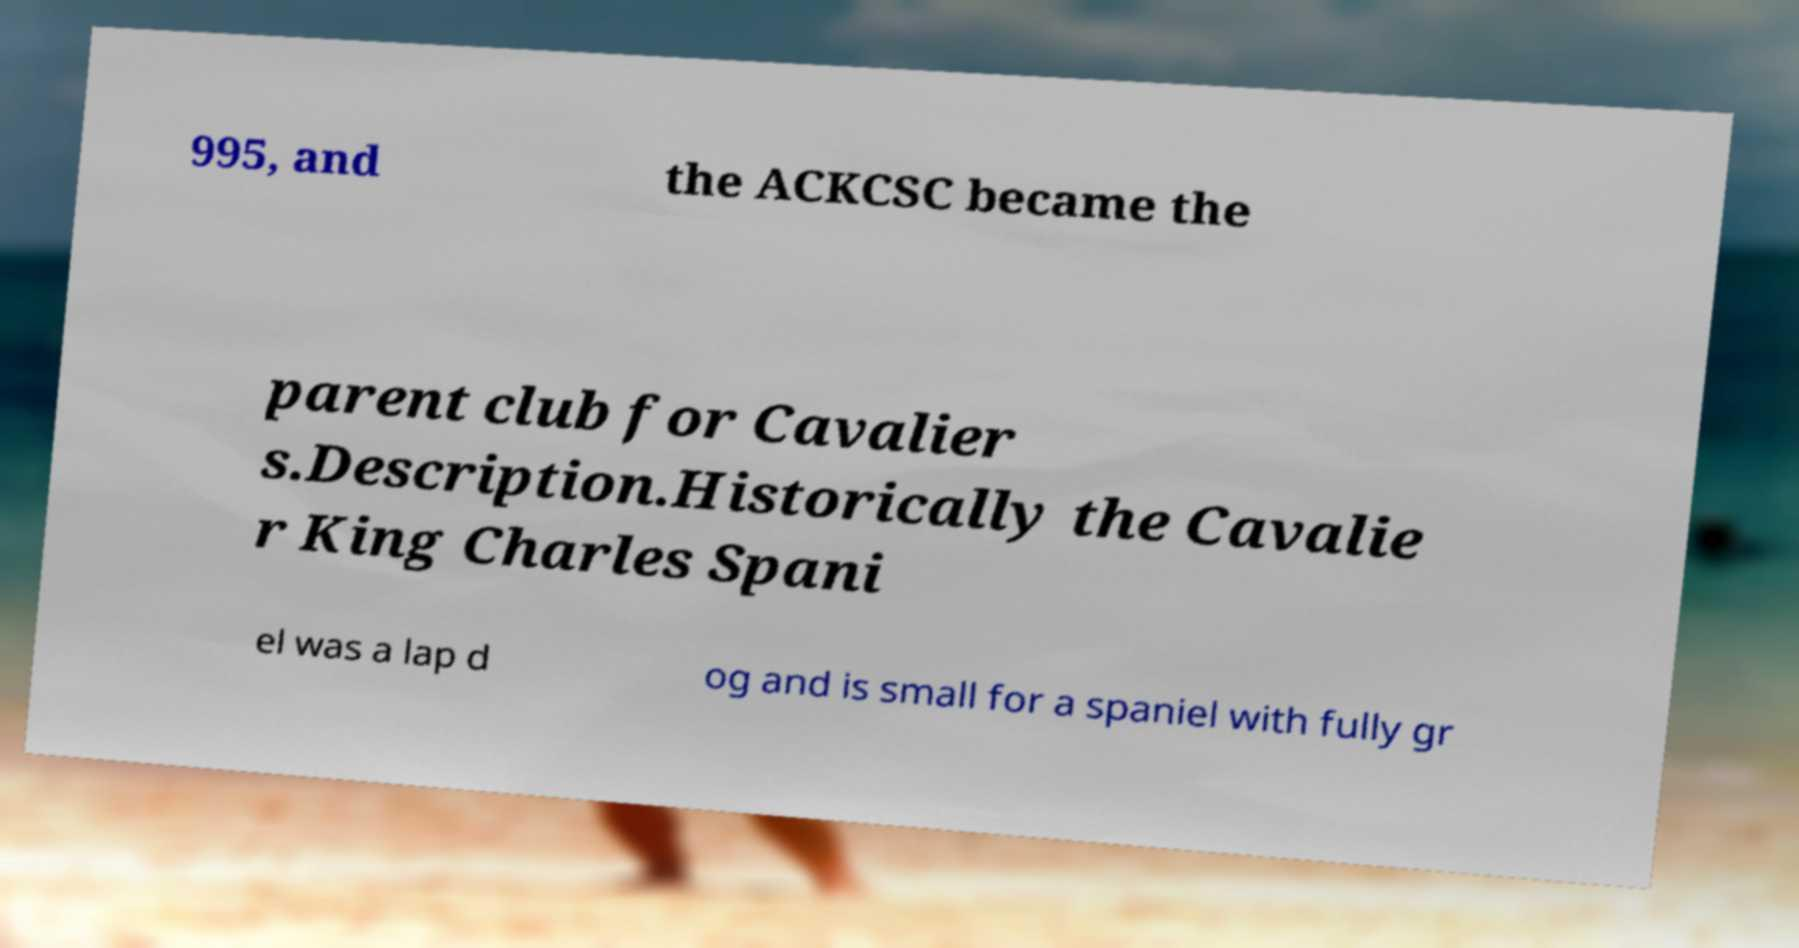Can you accurately transcribe the text from the provided image for me? 995, and the ACKCSC became the parent club for Cavalier s.Description.Historically the Cavalie r King Charles Spani el was a lap d og and is small for a spaniel with fully gr 